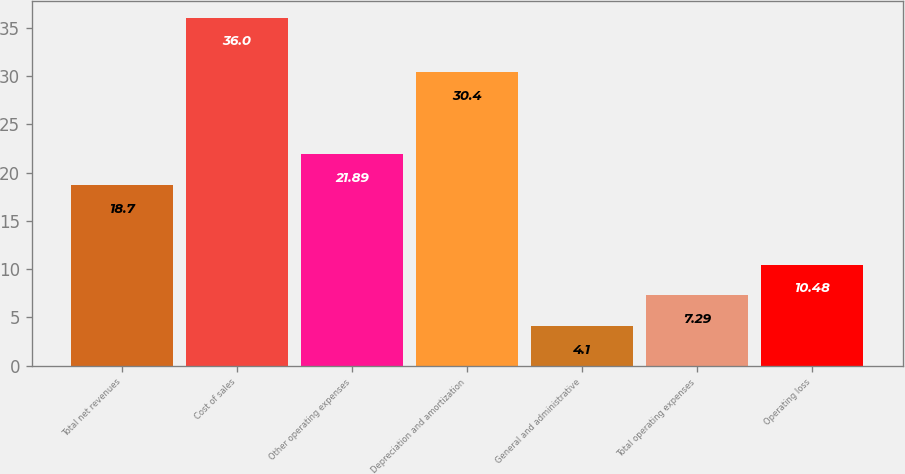<chart> <loc_0><loc_0><loc_500><loc_500><bar_chart><fcel>Total net revenues<fcel>Cost of sales<fcel>Other operating expenses<fcel>Depreciation and amortization<fcel>General and administrative<fcel>Total operating expenses<fcel>Operating loss<nl><fcel>18.7<fcel>36<fcel>21.89<fcel>30.4<fcel>4.1<fcel>7.29<fcel>10.48<nl></chart> 